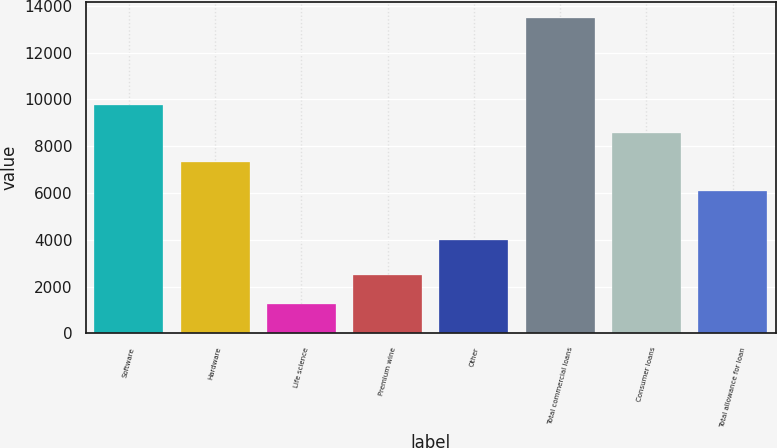<chart> <loc_0><loc_0><loc_500><loc_500><bar_chart><fcel>Software<fcel>Hardware<fcel>Life science<fcel>Premium wine<fcel>Other<fcel>Total commercial loans<fcel>Consumer loans<fcel>Total allowance for loan<nl><fcel>9766.1<fcel>7322.7<fcel>1277<fcel>2498.7<fcel>3982<fcel>13494<fcel>8544.4<fcel>6101<nl></chart> 